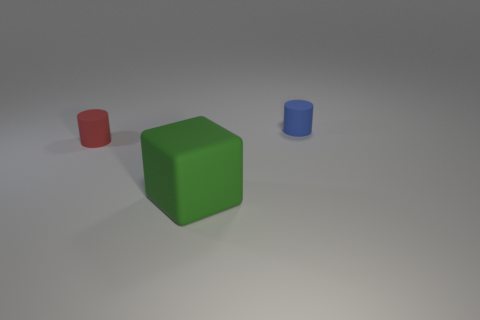Add 2 rubber cylinders. How many objects exist? 5 Subtract all blocks. How many objects are left? 2 Subtract 0 cyan cubes. How many objects are left? 3 Subtract all green rubber things. Subtract all green objects. How many objects are left? 1 Add 2 big green objects. How many big green objects are left? 3 Add 3 blue balls. How many blue balls exist? 3 